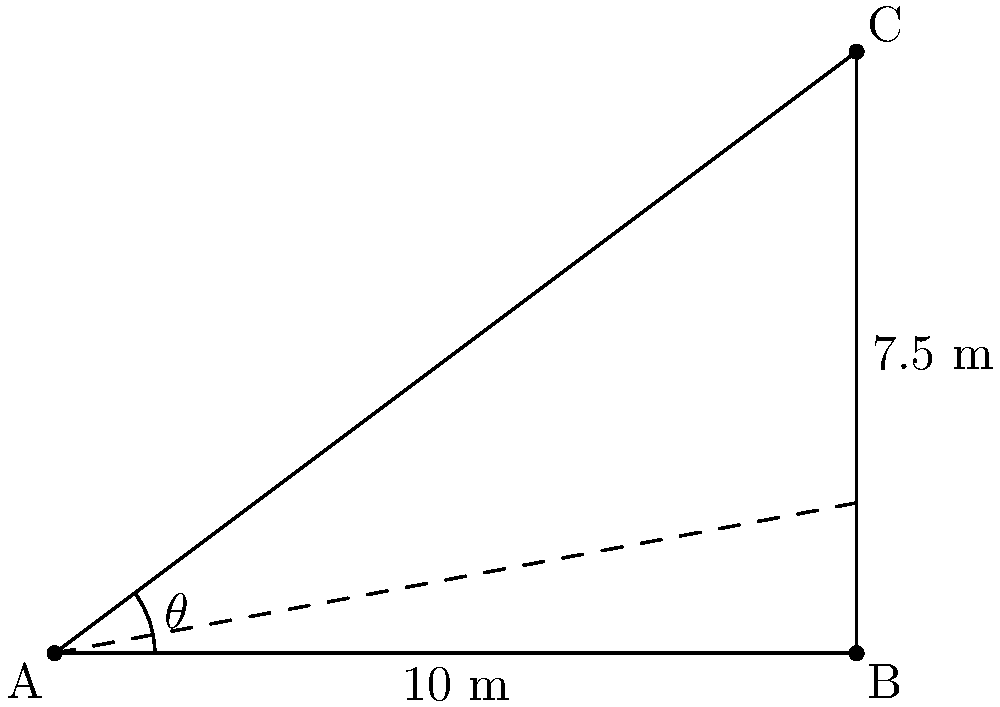You're playing with your new slingshot in the backyard. You want to hit a target that's 10 meters away and 7.5 meters high. What angle should you aim your slingshot at to hit the target? (Hint: Use the tangent function!) Let's solve this step-by-step:

1. First, we need to identify the right triangle in the problem. The ground forms the base, the target's height is the opposite side, and the line from you to the target is the hypotenuse.

2. We're looking for the angle of elevation, which is the angle between the ground and the line to the target. Let's call this angle $\theta$.

3. We know the opposite side (height) is 7.5 meters and the adjacent side (distance on ground) is 10 meters.

4. To find the angle when we know the opposite and adjacent sides, we use the tangent function:

   $\tan(\theta) = \frac{\text{opposite}}{\text{adjacent}} = \frac{7.5}{10}$

5. To get the angle, we need to use the inverse tangent (arctan or $\tan^{-1}$):

   $\theta = \tan^{-1}(\frac{7.5}{10})$

6. Using a calculator (or asking a grown-up to help), we can find that:

   $\theta \approx 36.87°$

So, you should aim your slingshot at an angle of about 37° to hit the target!
Answer: $37°$ 